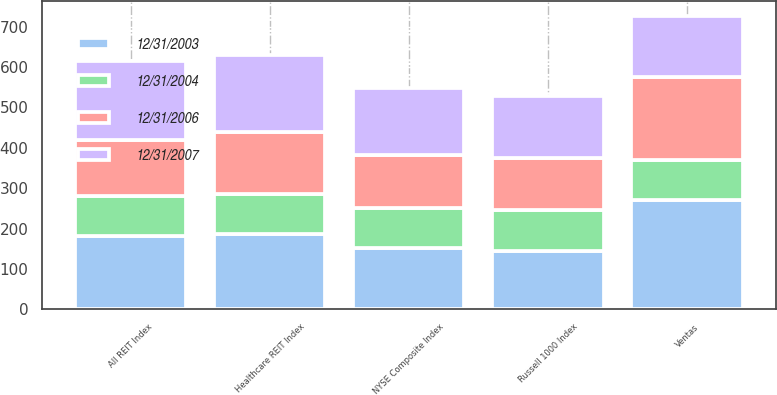Convert chart to OTSL. <chart><loc_0><loc_0><loc_500><loc_500><stacked_bar_chart><ecel><fcel>Ventas<fcel>NYSE Composite Index<fcel>All REIT Index<fcel>Healthcare REIT Index<fcel>Russell 1000 Index<nl><fcel>12/31/2004<fcel>100<fcel>100<fcel>100<fcel>100<fcel>100<nl><fcel>12/31/2006<fcel>206<fcel>132<fcel>138<fcel>154<fcel>130<nl><fcel>12/31/2003<fcel>270<fcel>151<fcel>181<fcel>186<fcel>145<nl><fcel>12/31/2007<fcel>151<fcel>166<fcel>196<fcel>189<fcel>154<nl></chart> 